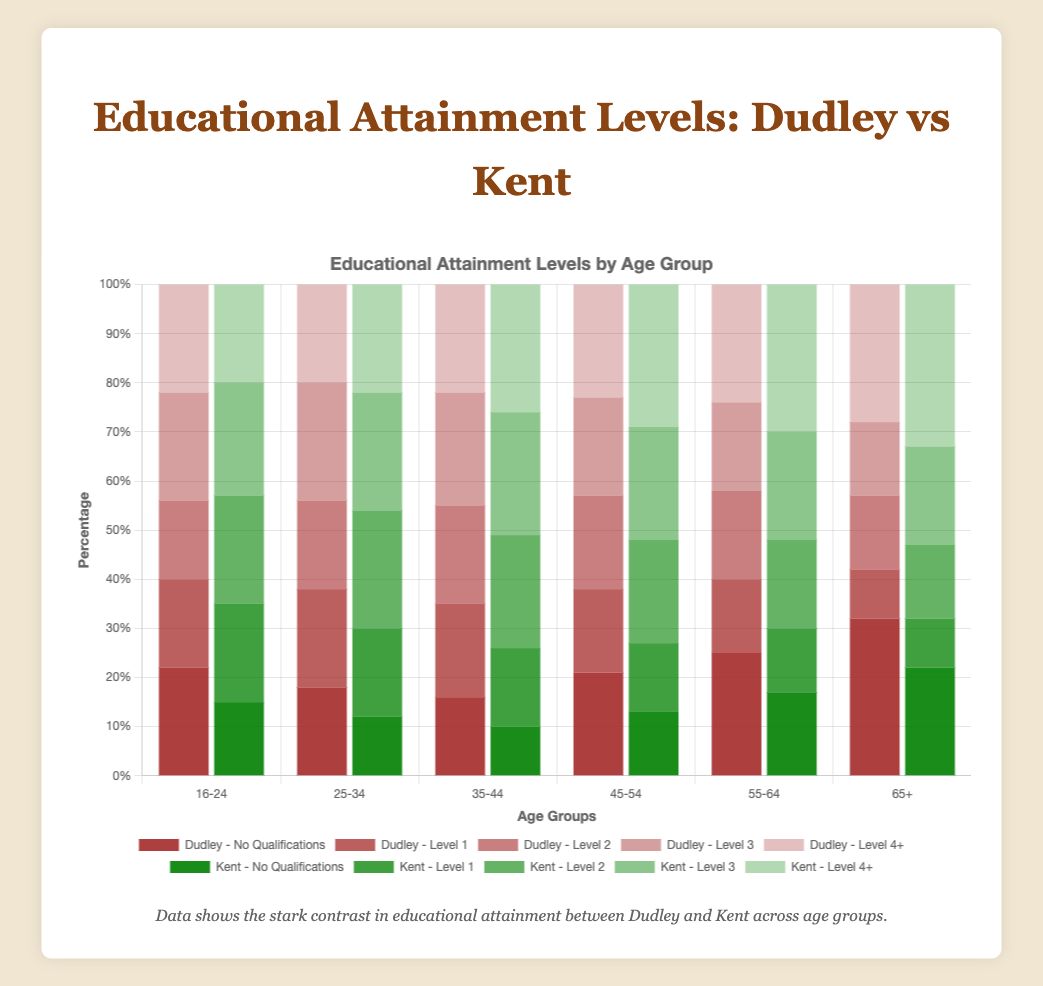what percentage of people aged 16-24 in Dudley have no qualifications? The red bar for "No Qualifications" in the "16-24" age group for Dudley is at 22%.
Answer: 22% Which age group in Kent has the highest percentage of Level 4+ qualifications? The highest green bar for "Level 4+" qualifications in Kent is in the "65+" age group, which is at 33%.
Answer: 65+ What is the difference in the percentage of people with Level 1 qualifications between Dudley and Kent in the 45-54 age group? For the 45-54 age group, the percentage of people with Level 1 qualifications in Dudley is 17%, and in Kent, it is 14%. The difference is 17% - 14% = 3%.
Answer: 3% How do the percentages of people aged 35-44 with Level 2 qualifications in Dudley compare to Kent? In the "35-44" age group, the height of the blue bar for Level 2 qualifications is 20% in Dudley and 23% in Kent.
Answer: Kent has 3% more What is the average percentage of people with No Qualifications across all age groups in Dudley? The percentages of people with No Qualifications in Dudley across age groups are [22, 18, 16, 21, 25, 32]. The sum is 22 + 18 + 16 + 21 + 25 + 32 = 134. The average is 134 / 6 = ~22.33%.
Answer: ~22.33% In which age group does Dudley have the lowest percentage of people with Level 3 qualifications? The lowest light blue bar for Level 3 qualifications in Dudley is at 15% in the "65+" age group.
Answer: 65+ What is the sum of the percentages of people aged 55-64 with Level 4+ qualifications in both Dudley and Kent? For the 55-64 age group, the percentage of people with Level 4+ qualifications is 24% in Dudley and 30% in Kent. The sum is 24% + 30% = 54%.
Answer: 54% How does the percentage of people aged 25-34 with No Qualifications in Dudley compare to that in Kent? In the "25-34" age group, the percentage of people with No Qualifications is 18% in Dudley and 12% in Kent. Dudley's percentage is higher by 18% - 12% = 6%.
Answer: Dudley has 6% more Which region has a higher percentage of people aged 45-54 with Level 2 qualifications? For the "45-54" age group, the height of the blue bar for Level 2 qualifications is 19% in Dudley and 21% in Kent.
Answer: Kent What is the combined percentage of people aged 16-24 with Level 1 and Level 3 qualifications in Kent? The percentages for Level 1 and Level 3 qualifications in the "16-24" age group in Kent are 20% and 23%, respectively. The combined percentage is 20% + 23% = 43%.
Answer: 43% 